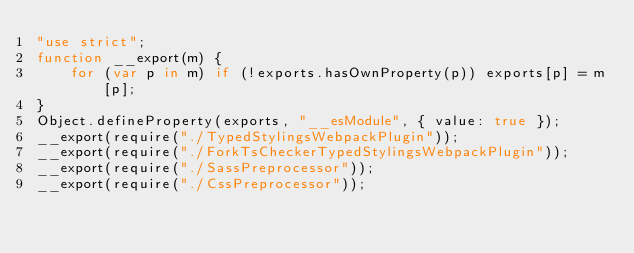Convert code to text. <code><loc_0><loc_0><loc_500><loc_500><_JavaScript_>"use strict";
function __export(m) {
    for (var p in m) if (!exports.hasOwnProperty(p)) exports[p] = m[p];
}
Object.defineProperty(exports, "__esModule", { value: true });
__export(require("./TypedStylingsWebpackPlugin"));
__export(require("./ForkTsCheckerTypedStylingsWebpackPlugin"));
__export(require("./SassPreprocessor"));
__export(require("./CssPreprocessor"));
</code> 